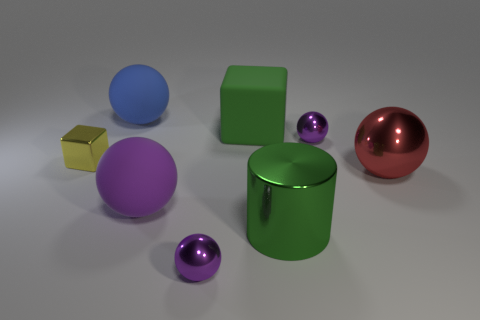What is the material of the other object that is the same shape as the green matte thing?
Keep it short and to the point. Metal. There is a block on the right side of the small purple thing that is in front of the purple ball that is behind the big purple object; what is it made of?
Give a very brief answer. Rubber. The purple matte object that is the same size as the matte block is what shape?
Provide a short and direct response. Sphere. Are there any other big metal cylinders of the same color as the large shiny cylinder?
Your answer should be very brief. No. The green matte thing has what size?
Offer a very short reply. Large. Is the material of the large cylinder the same as the big block?
Provide a succinct answer. No. There is a purple metal ball that is to the left of the metallic sphere that is behind the big red sphere; what number of large cylinders are in front of it?
Your answer should be very brief. 0. There is a tiny object on the left side of the blue thing; what shape is it?
Provide a succinct answer. Cube. How many other objects are there of the same material as the red sphere?
Make the answer very short. 4. Does the cylinder have the same color as the big rubber cube?
Give a very brief answer. Yes. 